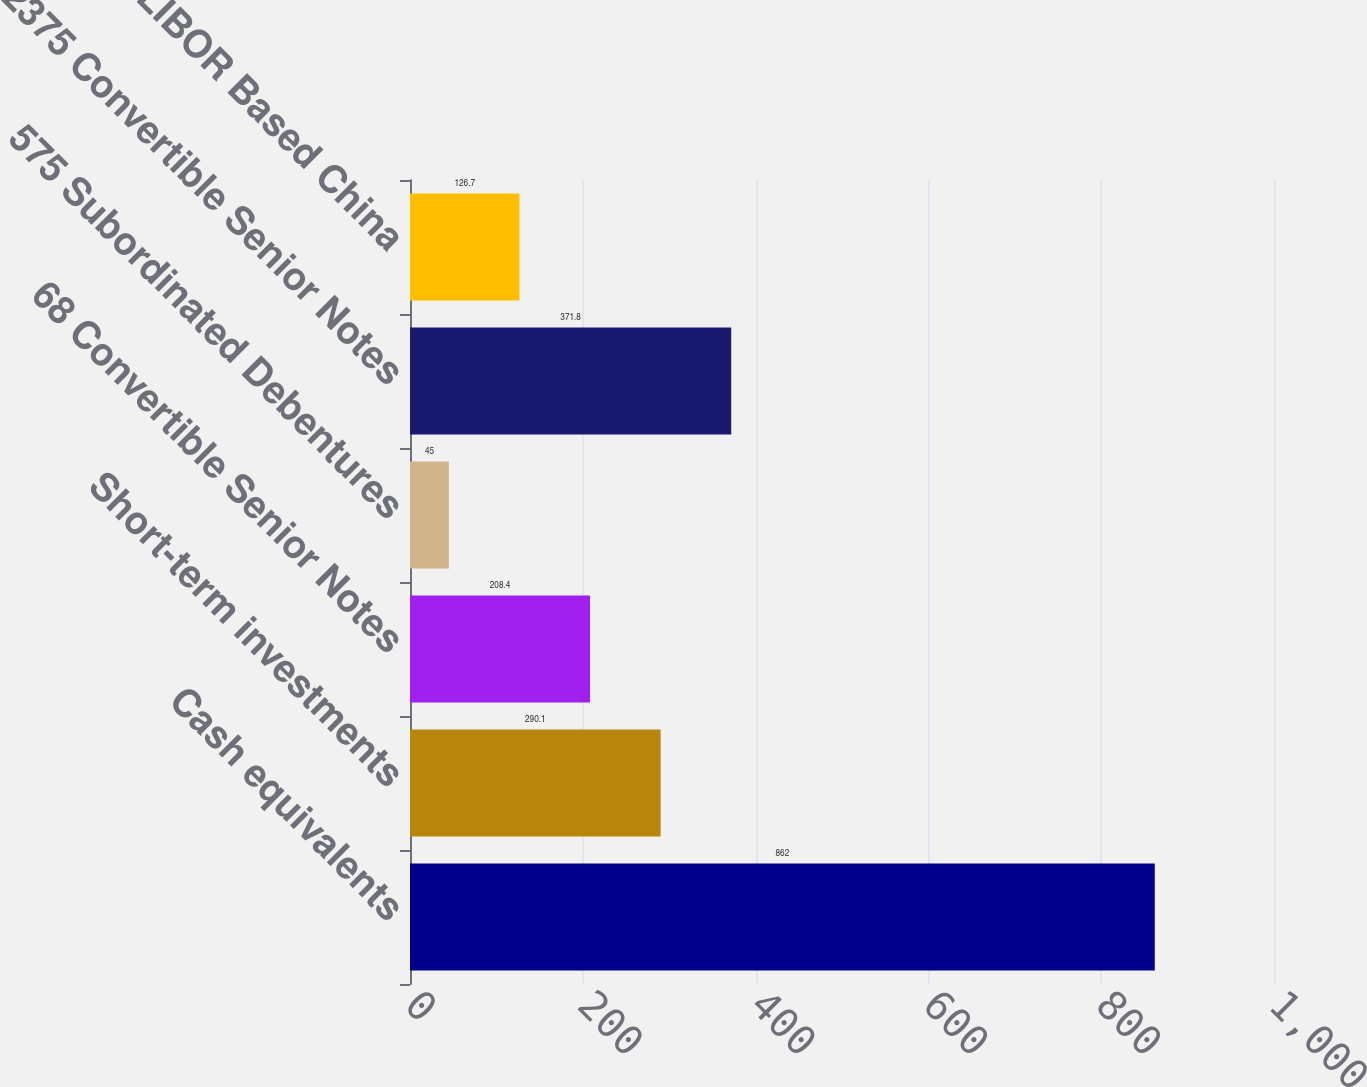Convert chart to OTSL. <chart><loc_0><loc_0><loc_500><loc_500><bar_chart><fcel>Cash equivalents<fcel>Short-term investments<fcel>68 Convertible Senior Notes<fcel>575 Subordinated Debentures<fcel>2375 Convertible Senior Notes<fcel>LIBOR Based China<nl><fcel>862<fcel>290.1<fcel>208.4<fcel>45<fcel>371.8<fcel>126.7<nl></chart> 